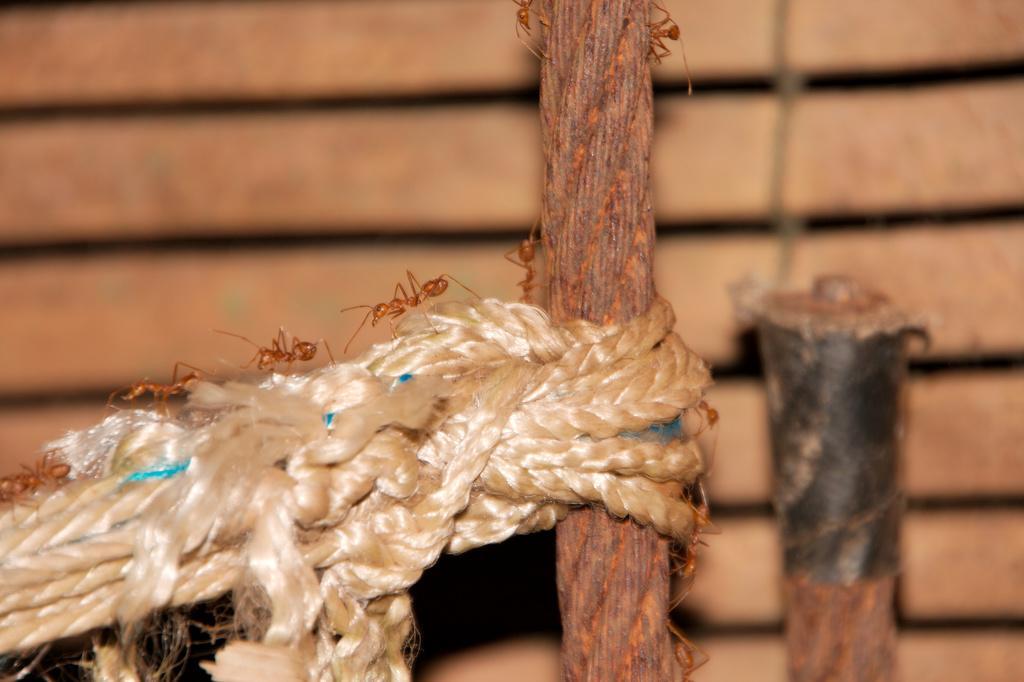Please provide a concise description of this image. In the picture I can see ropes on which there are some ants walking and the background image is blur. 